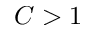Convert formula to latex. <formula><loc_0><loc_0><loc_500><loc_500>C > 1</formula> 